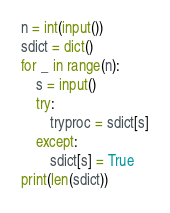Convert code to text. <code><loc_0><loc_0><loc_500><loc_500><_Python_>n = int(input())
sdict = dict()
for _ in range(n):
    s = input()
    try:
        tryproc = sdict[s]
    except:
        sdict[s] = True
print(len(sdict))</code> 